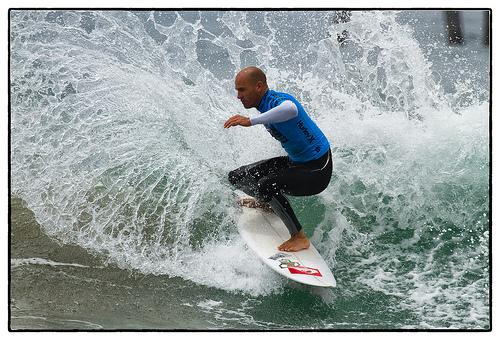Highlight the predominant colors and their corresponding objects in the image. The image features white and green ocean waves, a blue rash guard, a white surfboard with a red logo, and dark brown ocean water. In the context of the image, describe the appearance of the waves. The waves are white and green, with large splashes and sprays of ocean water, and calm water is visible preceding the main wave. Describe the surfer's attire in the image. The surfer is wearing a blue rash guard, black pants of a wet suit, and a white wet suit sleeve while riding the wave. Illustrate the position and appearance of the red logo in the image. The red logo is located on the white surfboard that the man is riding and appears to be a small, distinct emblem in the lower half of the board. Provide a brief overview of the scene depicted in the image. A man is surfing on a wave while riding a white surfboard with a red logo, surrounded by white and green ocean waves and a pier with wooden pillars. How is the surfer maintaining balance on the surfboard in the image? The surfer is squatting on the board with a sharply bent knee and extending a curved hand at the end of his arm to maintain balance. What is the state of the water in the image, particularly around the man surfing? The water around the man is churning, with large splashes and sprays of ocean water as he rides the wave on his white surfboard. What are the prominent visual elements related to the surfer's surfboard? The prominent visual elements are the white surfboard, the red logo on it, and the black design on the side of the board. Mention the key elements in the image related to the surfer's actions. A man is riding a wave on a white surfboard, squatting down with a bent knee, and extending his curved hand for balance. Give a concise summary of the main activity happening in the image. An adult male surfer is skillfully riding a wave on a white surfboard with a red logo, surrounded by churning water and ocean waves. 